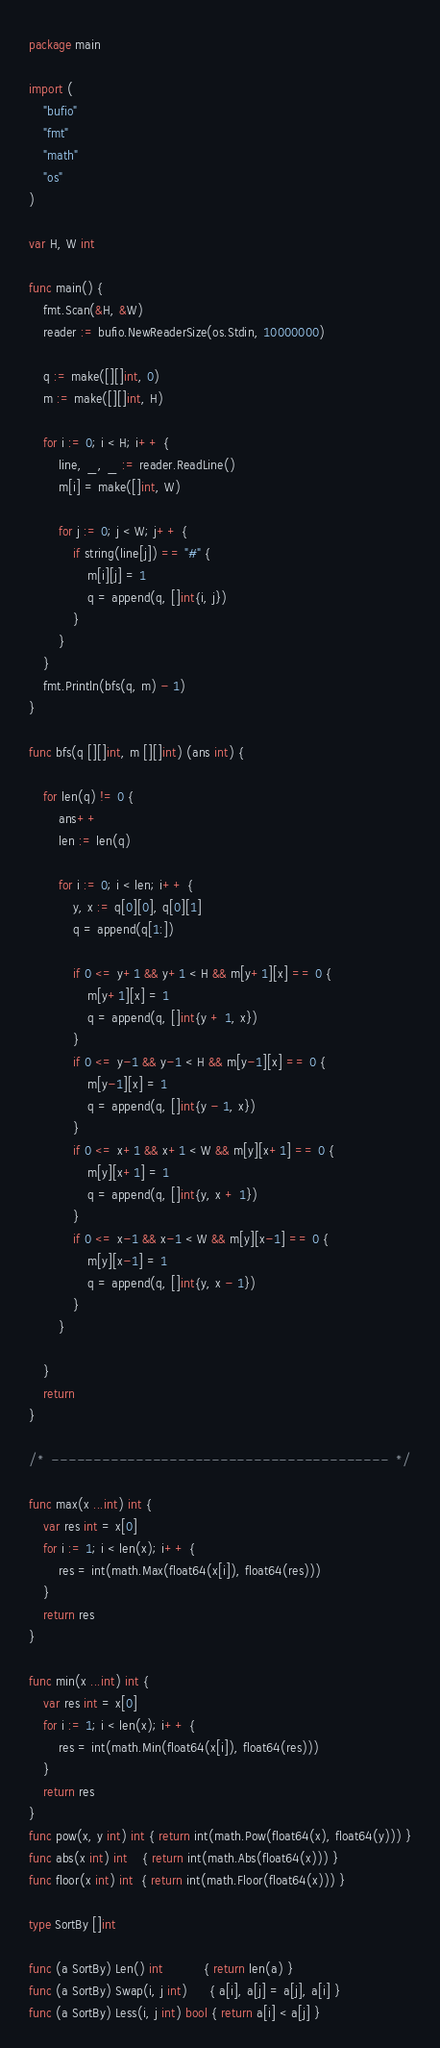<code> <loc_0><loc_0><loc_500><loc_500><_Go_>package main

import (
	"bufio"
	"fmt"
	"math"
	"os"
)

var H, W int

func main() {
	fmt.Scan(&H, &W)
	reader := bufio.NewReaderSize(os.Stdin, 10000000)

	q := make([][]int, 0)
	m := make([][]int, H)

	for i := 0; i < H; i++ {
		line, _, _ := reader.ReadLine()
		m[i] = make([]int, W)

		for j := 0; j < W; j++ {
			if string(line[j]) == "#" {
				m[i][j] = 1
				q = append(q, []int{i, j})
			}
		}
	}
	fmt.Println(bfs(q, m) - 1)
}

func bfs(q [][]int, m [][]int) (ans int) {

	for len(q) != 0 {
		ans++
		len := len(q)

		for i := 0; i < len; i++ {
			y, x := q[0][0], q[0][1]
			q = append(q[1:])

			if 0 <= y+1 && y+1 < H && m[y+1][x] == 0 {
				m[y+1][x] = 1
				q = append(q, []int{y + 1, x})
			}
			if 0 <= y-1 && y-1 < H && m[y-1][x] == 0 {
				m[y-1][x] = 1
				q = append(q, []int{y - 1, x})
			}
			if 0 <= x+1 && x+1 < W && m[y][x+1] == 0 {
				m[y][x+1] = 1
				q = append(q, []int{y, x + 1})
			}
			if 0 <= x-1 && x-1 < W && m[y][x-1] == 0 {
				m[y][x-1] = 1
				q = append(q, []int{y, x - 1})
			}
		}

	}
	return
}

/*  ----------------------------------------  */

func max(x ...int) int {
	var res int = x[0]
	for i := 1; i < len(x); i++ {
		res = int(math.Max(float64(x[i]), float64(res)))
	}
	return res
}

func min(x ...int) int {
	var res int = x[0]
	for i := 1; i < len(x); i++ {
		res = int(math.Min(float64(x[i]), float64(res)))
	}
	return res
}
func pow(x, y int) int { return int(math.Pow(float64(x), float64(y))) }
func abs(x int) int    { return int(math.Abs(float64(x))) }
func floor(x int) int  { return int(math.Floor(float64(x))) }

type SortBy []int

func (a SortBy) Len() int           { return len(a) }
func (a SortBy) Swap(i, j int)      { a[i], a[j] = a[j], a[i] }
func (a SortBy) Less(i, j int) bool { return a[i] < a[j] }
</code> 